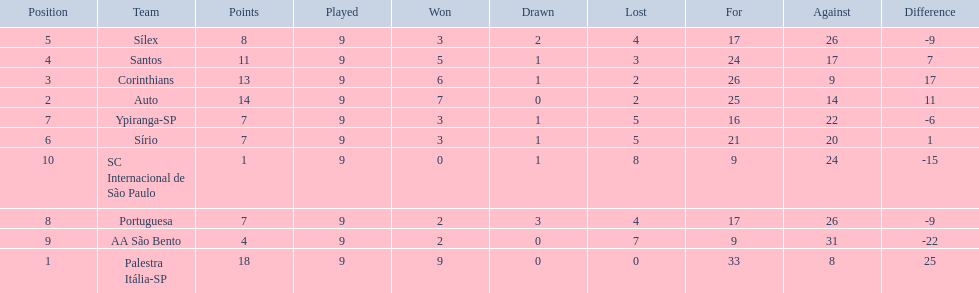Which teams were playing brazilian football in 1926? Palestra Itália-SP, Auto, Corinthians, Santos, Sílex, Sírio, Ypiranga-SP, Portuguesa, AA São Bento, SC Internacional de São Paulo. Of those teams, which one scored 13 points? Corinthians. 